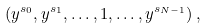<formula> <loc_0><loc_0><loc_500><loc_500>( y ^ { s _ { 0 } } , y ^ { s _ { 1 } } , \dots , 1 , \dots , y ^ { s _ { N - 1 } } ) \, ,</formula> 